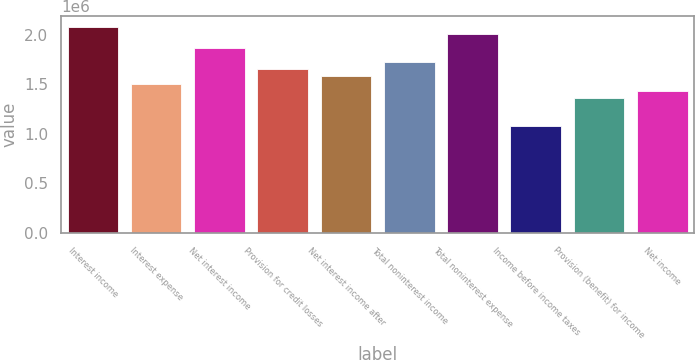Convert chart to OTSL. <chart><loc_0><loc_0><loc_500><loc_500><bar_chart><fcel>Interest income<fcel>Interest expense<fcel>Net interest income<fcel>Provision for credit losses<fcel>Net interest income after<fcel>Total noninterest income<fcel>Total noninterest expense<fcel>Income before income taxes<fcel>Provision (benefit) for income<fcel>Net income<nl><fcel>2.08392e+06<fcel>1.50905e+06<fcel>1.86834e+06<fcel>1.65276e+06<fcel>1.5809e+06<fcel>1.72462e+06<fcel>2.01206e+06<fcel>1.07789e+06<fcel>1.36533e+06<fcel>1.43719e+06<nl></chart> 